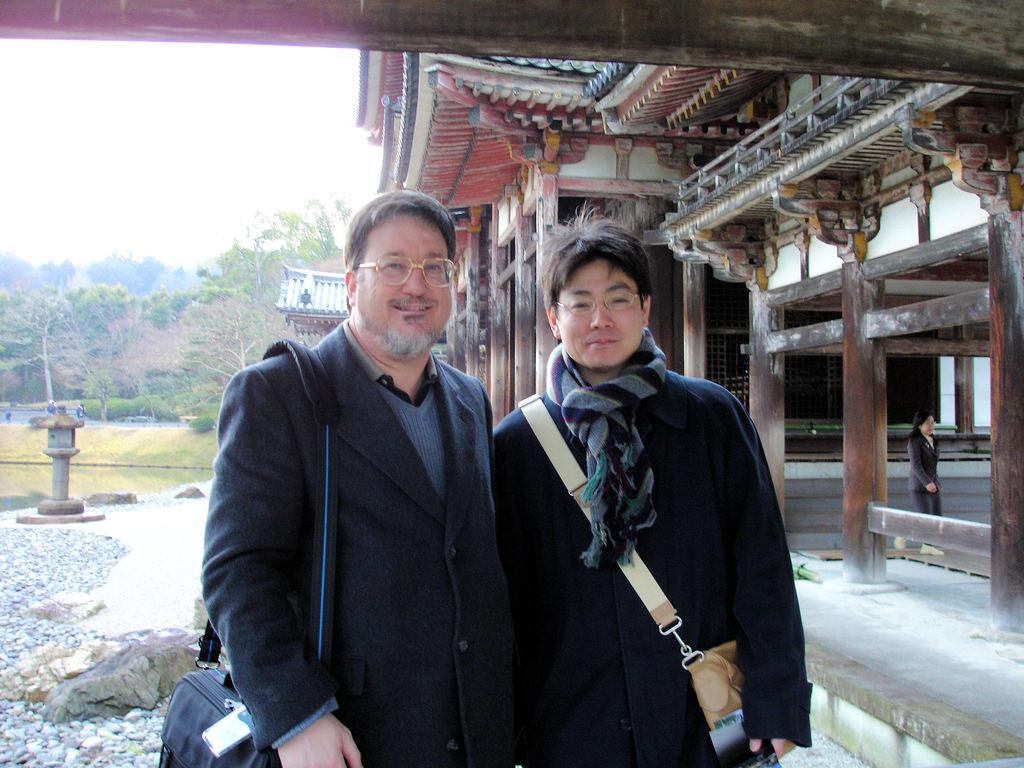How many people are in the image? There is a group of people in the image. Can you describe the two men in the middle of the image? Two men are present in the middle of the image, and they are wearing bags and spectacles. What can be seen in the background of the image? There are houses and trees in the background of the image. What type of plant did the men agree on in the image? There is no mention of a plant or an agreement in the image. 